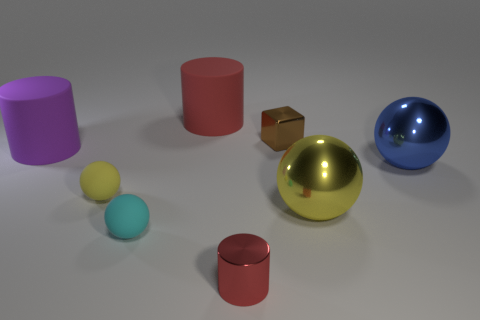How many cyan matte spheres have the same size as the red metal object?
Make the answer very short. 1. Does the block have the same size as the cyan ball?
Keep it short and to the point. Yes. How big is the thing that is both behind the yellow metallic object and in front of the blue shiny object?
Your answer should be compact. Small. Are there more big yellow balls in front of the red matte cylinder than small yellow things in front of the tiny red metallic cylinder?
Your answer should be very brief. Yes. There is a metal object that is the same shape as the red matte object; what color is it?
Offer a terse response. Red. There is a big cylinder that is on the right side of the large purple rubber cylinder; is it the same color as the tiny metallic cylinder?
Make the answer very short. Yes. How many matte things are there?
Provide a succinct answer. 4. Do the cylinder in front of the yellow shiny object and the brown object have the same material?
Ensure brevity in your answer.  Yes. There is a big object behind the large cylinder left of the small yellow matte object; how many large purple rubber things are to the left of it?
Your response must be concise. 1. What size is the red rubber object?
Your response must be concise. Large. 